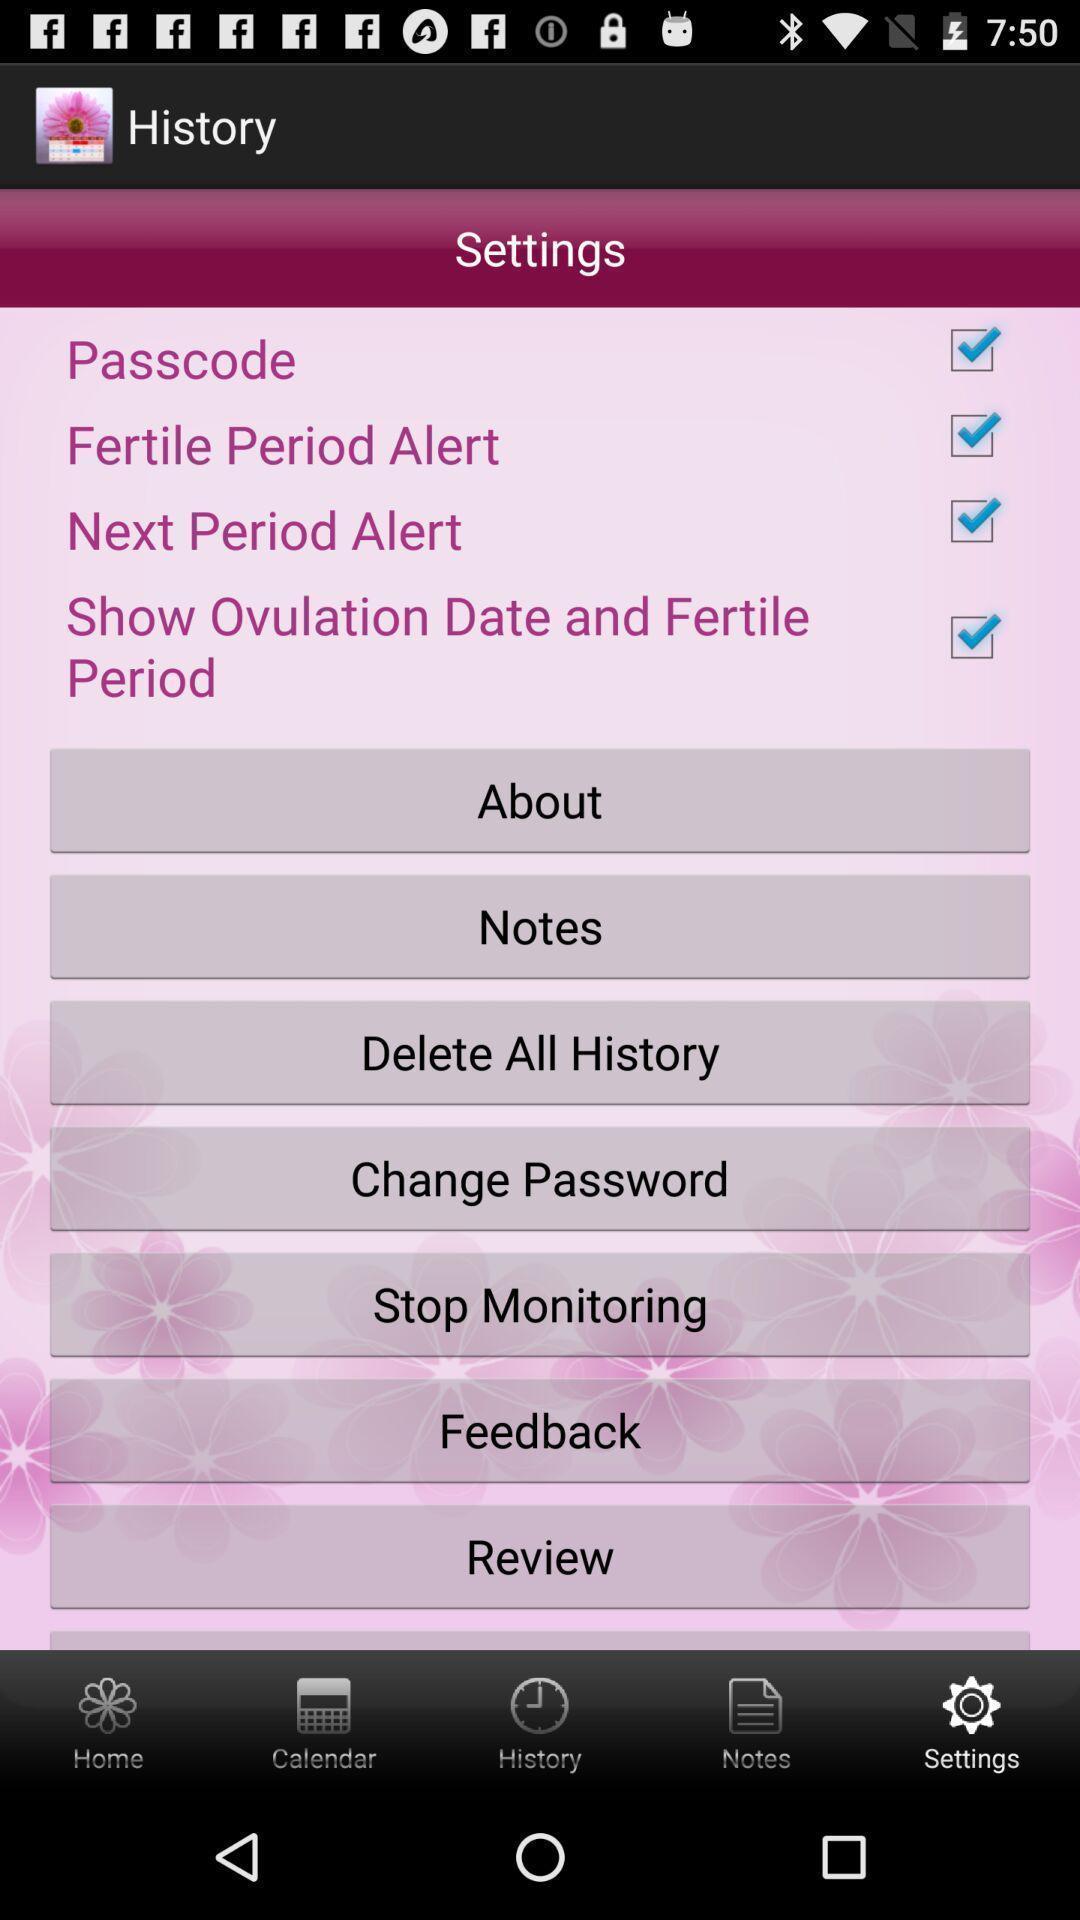Summarize the main components in this picture. Settings window to monitor periods. 